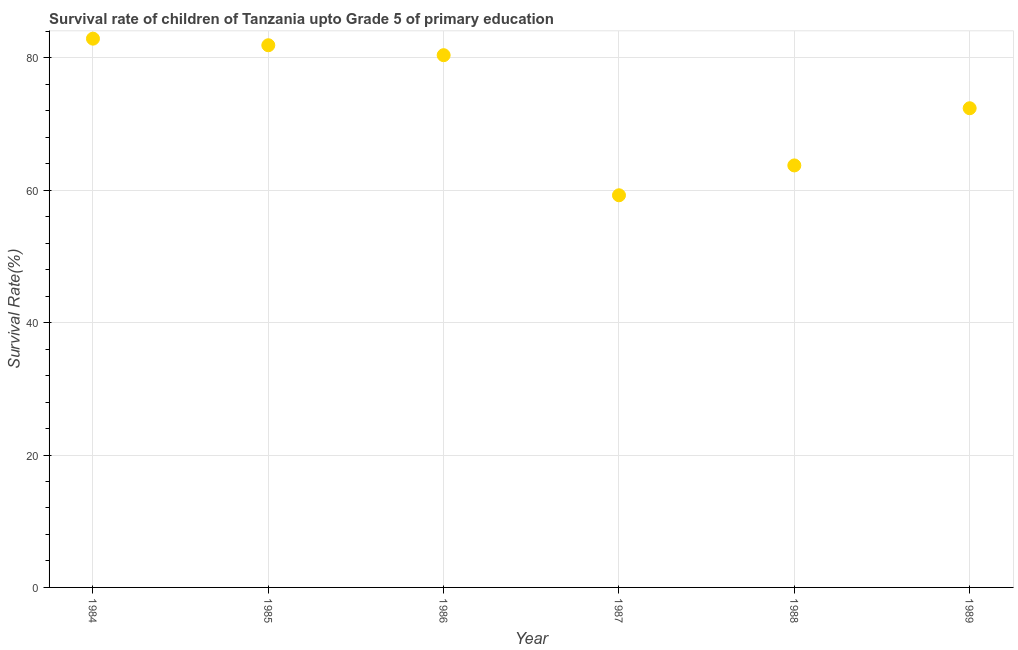What is the survival rate in 1987?
Ensure brevity in your answer.  59.23. Across all years, what is the maximum survival rate?
Provide a succinct answer. 82.88. Across all years, what is the minimum survival rate?
Give a very brief answer. 59.23. In which year was the survival rate maximum?
Your response must be concise. 1984. What is the sum of the survival rate?
Provide a short and direct response. 440.49. What is the difference between the survival rate in 1986 and 1988?
Ensure brevity in your answer.  16.65. What is the average survival rate per year?
Your response must be concise. 73.42. What is the median survival rate?
Offer a terse response. 76.38. What is the ratio of the survival rate in 1987 to that in 1988?
Provide a succinct answer. 0.93. Is the difference between the survival rate in 1984 and 1987 greater than the difference between any two years?
Give a very brief answer. Yes. What is the difference between the highest and the second highest survival rate?
Make the answer very short. 1. Is the sum of the survival rate in 1986 and 1988 greater than the maximum survival rate across all years?
Offer a terse response. Yes. What is the difference between the highest and the lowest survival rate?
Give a very brief answer. 23.66. In how many years, is the survival rate greater than the average survival rate taken over all years?
Offer a terse response. 3. How many years are there in the graph?
Your answer should be very brief. 6. What is the difference between two consecutive major ticks on the Y-axis?
Your response must be concise. 20. Are the values on the major ticks of Y-axis written in scientific E-notation?
Your answer should be very brief. No. What is the title of the graph?
Offer a terse response. Survival rate of children of Tanzania upto Grade 5 of primary education. What is the label or title of the Y-axis?
Keep it short and to the point. Survival Rate(%). What is the Survival Rate(%) in 1984?
Provide a short and direct response. 82.88. What is the Survival Rate(%) in 1985?
Provide a short and direct response. 81.89. What is the Survival Rate(%) in 1986?
Your response must be concise. 80.39. What is the Survival Rate(%) in 1987?
Offer a terse response. 59.23. What is the Survival Rate(%) in 1988?
Offer a very short reply. 63.74. What is the Survival Rate(%) in 1989?
Your response must be concise. 72.37. What is the difference between the Survival Rate(%) in 1984 and 1985?
Offer a very short reply. 1. What is the difference between the Survival Rate(%) in 1984 and 1986?
Provide a succinct answer. 2.5. What is the difference between the Survival Rate(%) in 1984 and 1987?
Your response must be concise. 23.66. What is the difference between the Survival Rate(%) in 1984 and 1988?
Keep it short and to the point. 19.15. What is the difference between the Survival Rate(%) in 1984 and 1989?
Provide a succinct answer. 10.51. What is the difference between the Survival Rate(%) in 1985 and 1986?
Make the answer very short. 1.5. What is the difference between the Survival Rate(%) in 1985 and 1987?
Your answer should be very brief. 22.66. What is the difference between the Survival Rate(%) in 1985 and 1988?
Offer a terse response. 18.15. What is the difference between the Survival Rate(%) in 1985 and 1989?
Your response must be concise. 9.51. What is the difference between the Survival Rate(%) in 1986 and 1987?
Your response must be concise. 21.16. What is the difference between the Survival Rate(%) in 1986 and 1988?
Provide a short and direct response. 16.65. What is the difference between the Survival Rate(%) in 1986 and 1989?
Give a very brief answer. 8.01. What is the difference between the Survival Rate(%) in 1987 and 1988?
Your answer should be very brief. -4.51. What is the difference between the Survival Rate(%) in 1987 and 1989?
Your answer should be compact. -13.15. What is the difference between the Survival Rate(%) in 1988 and 1989?
Make the answer very short. -8.64. What is the ratio of the Survival Rate(%) in 1984 to that in 1986?
Your response must be concise. 1.03. What is the ratio of the Survival Rate(%) in 1984 to that in 1987?
Give a very brief answer. 1.4. What is the ratio of the Survival Rate(%) in 1984 to that in 1989?
Your answer should be very brief. 1.15. What is the ratio of the Survival Rate(%) in 1985 to that in 1987?
Your answer should be very brief. 1.38. What is the ratio of the Survival Rate(%) in 1985 to that in 1988?
Provide a succinct answer. 1.28. What is the ratio of the Survival Rate(%) in 1985 to that in 1989?
Give a very brief answer. 1.13. What is the ratio of the Survival Rate(%) in 1986 to that in 1987?
Provide a short and direct response. 1.36. What is the ratio of the Survival Rate(%) in 1986 to that in 1988?
Your answer should be compact. 1.26. What is the ratio of the Survival Rate(%) in 1986 to that in 1989?
Your answer should be compact. 1.11. What is the ratio of the Survival Rate(%) in 1987 to that in 1988?
Offer a terse response. 0.93. What is the ratio of the Survival Rate(%) in 1987 to that in 1989?
Provide a succinct answer. 0.82. What is the ratio of the Survival Rate(%) in 1988 to that in 1989?
Your answer should be very brief. 0.88. 